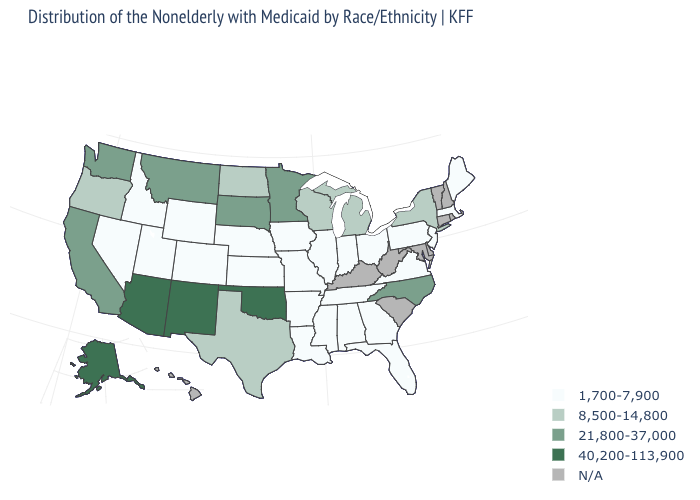Does the first symbol in the legend represent the smallest category?
Answer briefly. Yes. How many symbols are there in the legend?
Keep it brief. 5. What is the value of Arkansas?
Give a very brief answer. 1,700-7,900. What is the value of Colorado?
Answer briefly. 1,700-7,900. Does Missouri have the lowest value in the USA?
Short answer required. Yes. How many symbols are there in the legend?
Keep it brief. 5. What is the value of Nevada?
Give a very brief answer. 1,700-7,900. Among the states that border Michigan , which have the lowest value?
Quick response, please. Indiana, Ohio. Which states have the lowest value in the USA?
Short answer required. Alabama, Arkansas, Colorado, Florida, Georgia, Idaho, Illinois, Indiana, Iowa, Kansas, Louisiana, Maine, Massachusetts, Mississippi, Missouri, Nebraska, Nevada, New Jersey, Ohio, Pennsylvania, Tennessee, Utah, Virginia, Wyoming. What is the highest value in states that border Texas?
Be succinct. 40,200-113,900. Among the states that border Louisiana , does Arkansas have the lowest value?
Concise answer only. Yes. Name the states that have a value in the range N/A?
Answer briefly. Connecticut, Delaware, Hawaii, Kentucky, Maryland, New Hampshire, Rhode Island, South Carolina, Vermont, West Virginia. Name the states that have a value in the range 40,200-113,900?
Write a very short answer. Alaska, Arizona, New Mexico, Oklahoma. 